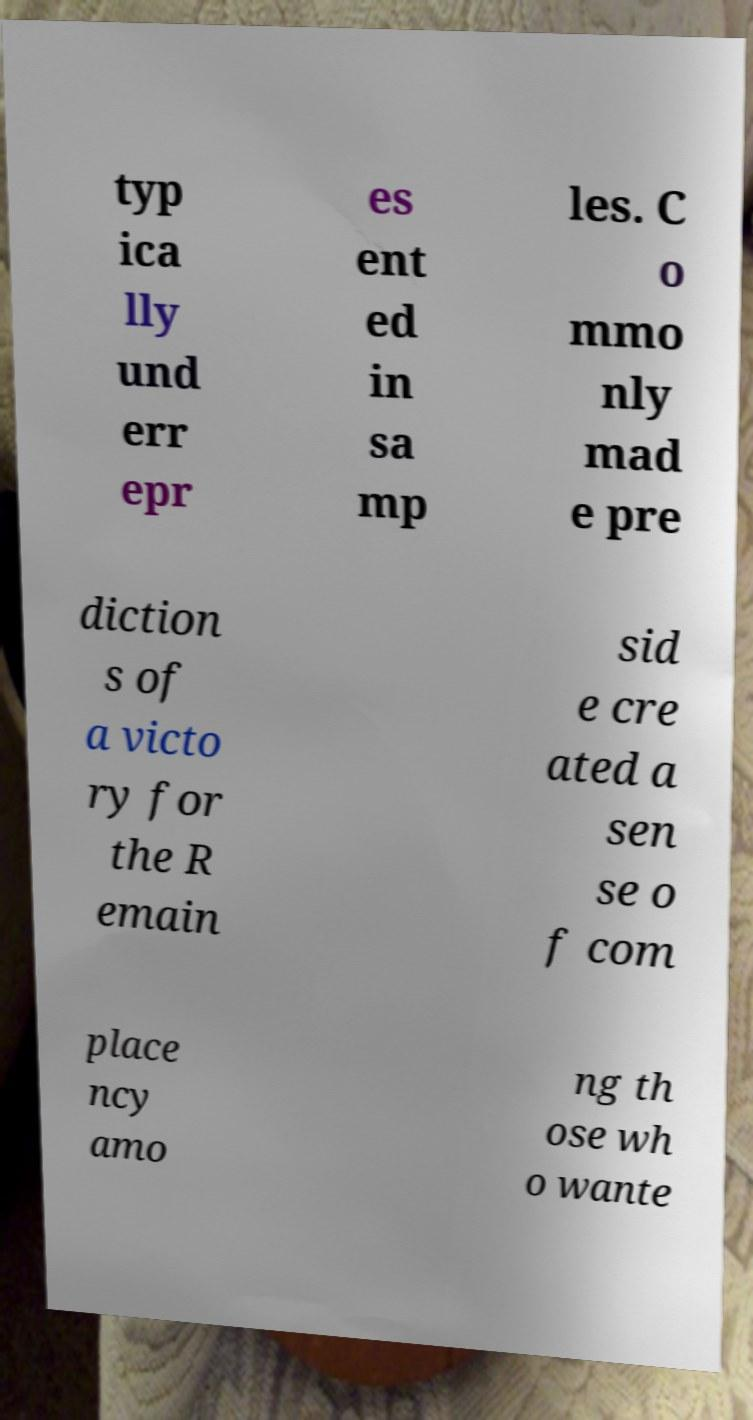Can you accurately transcribe the text from the provided image for me? typ ica lly und err epr es ent ed in sa mp les. C o mmo nly mad e pre diction s of a victo ry for the R emain sid e cre ated a sen se o f com place ncy amo ng th ose wh o wante 